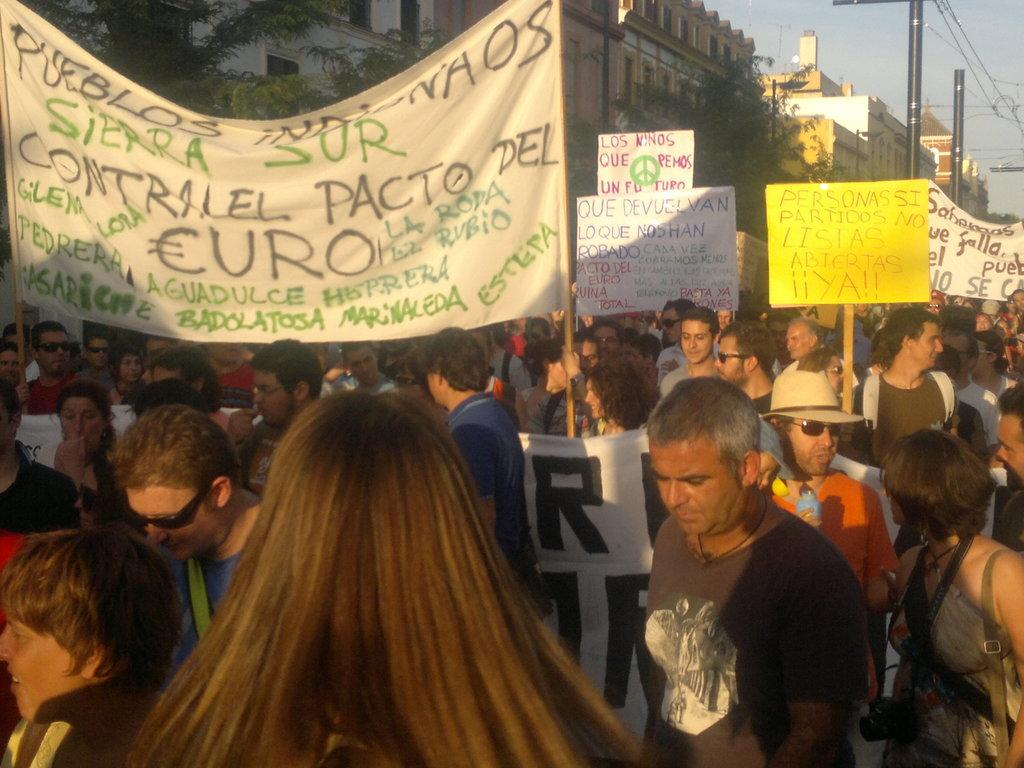What are the people in the image holding? The people in the image are holding placards. What can be seen in the background of the image? There are trees, buildings, poles, and the sky visible in the background of the image. Can you see a boy playing with a cat near the gate in the image? There is no boy, cat, or gate present in the image. 